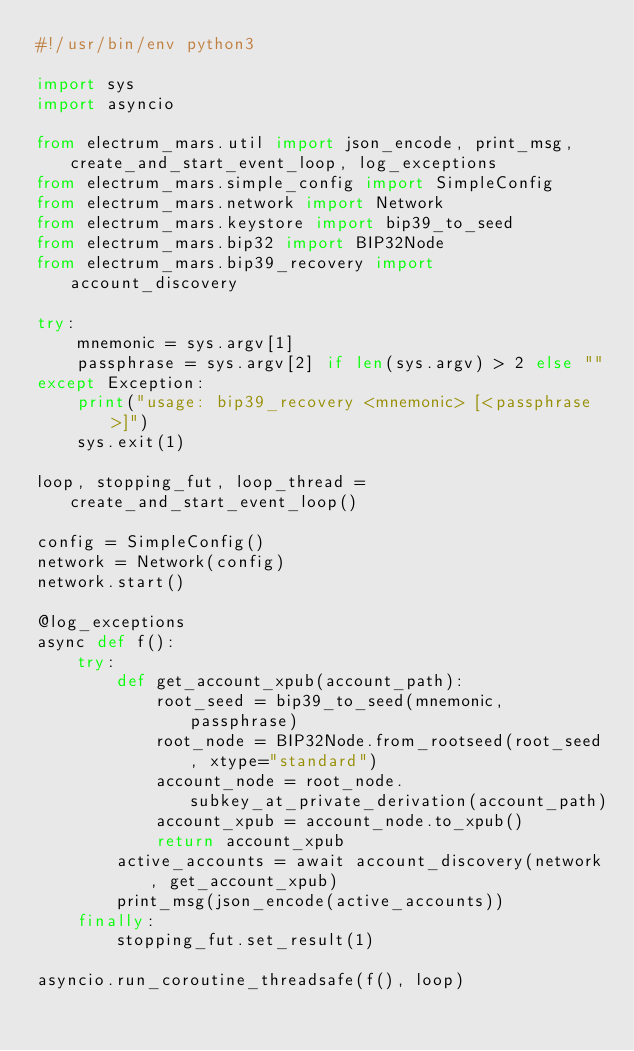<code> <loc_0><loc_0><loc_500><loc_500><_Python_>#!/usr/bin/env python3

import sys
import asyncio

from electrum_mars.util import json_encode, print_msg, create_and_start_event_loop, log_exceptions
from electrum_mars.simple_config import SimpleConfig
from electrum_mars.network import Network
from electrum_mars.keystore import bip39_to_seed
from electrum_mars.bip32 import BIP32Node
from electrum_mars.bip39_recovery import account_discovery

try:
    mnemonic = sys.argv[1]
    passphrase = sys.argv[2] if len(sys.argv) > 2 else ""
except Exception:
    print("usage: bip39_recovery <mnemonic> [<passphrase>]")
    sys.exit(1)

loop, stopping_fut, loop_thread = create_and_start_event_loop()

config = SimpleConfig()
network = Network(config)
network.start()

@log_exceptions
async def f():
    try:
        def get_account_xpub(account_path):
            root_seed = bip39_to_seed(mnemonic, passphrase)
            root_node = BIP32Node.from_rootseed(root_seed, xtype="standard")
            account_node = root_node.subkey_at_private_derivation(account_path)
            account_xpub = account_node.to_xpub()
            return account_xpub
        active_accounts = await account_discovery(network, get_account_xpub)
        print_msg(json_encode(active_accounts))
    finally:
        stopping_fut.set_result(1)

asyncio.run_coroutine_threadsafe(f(), loop)
</code> 